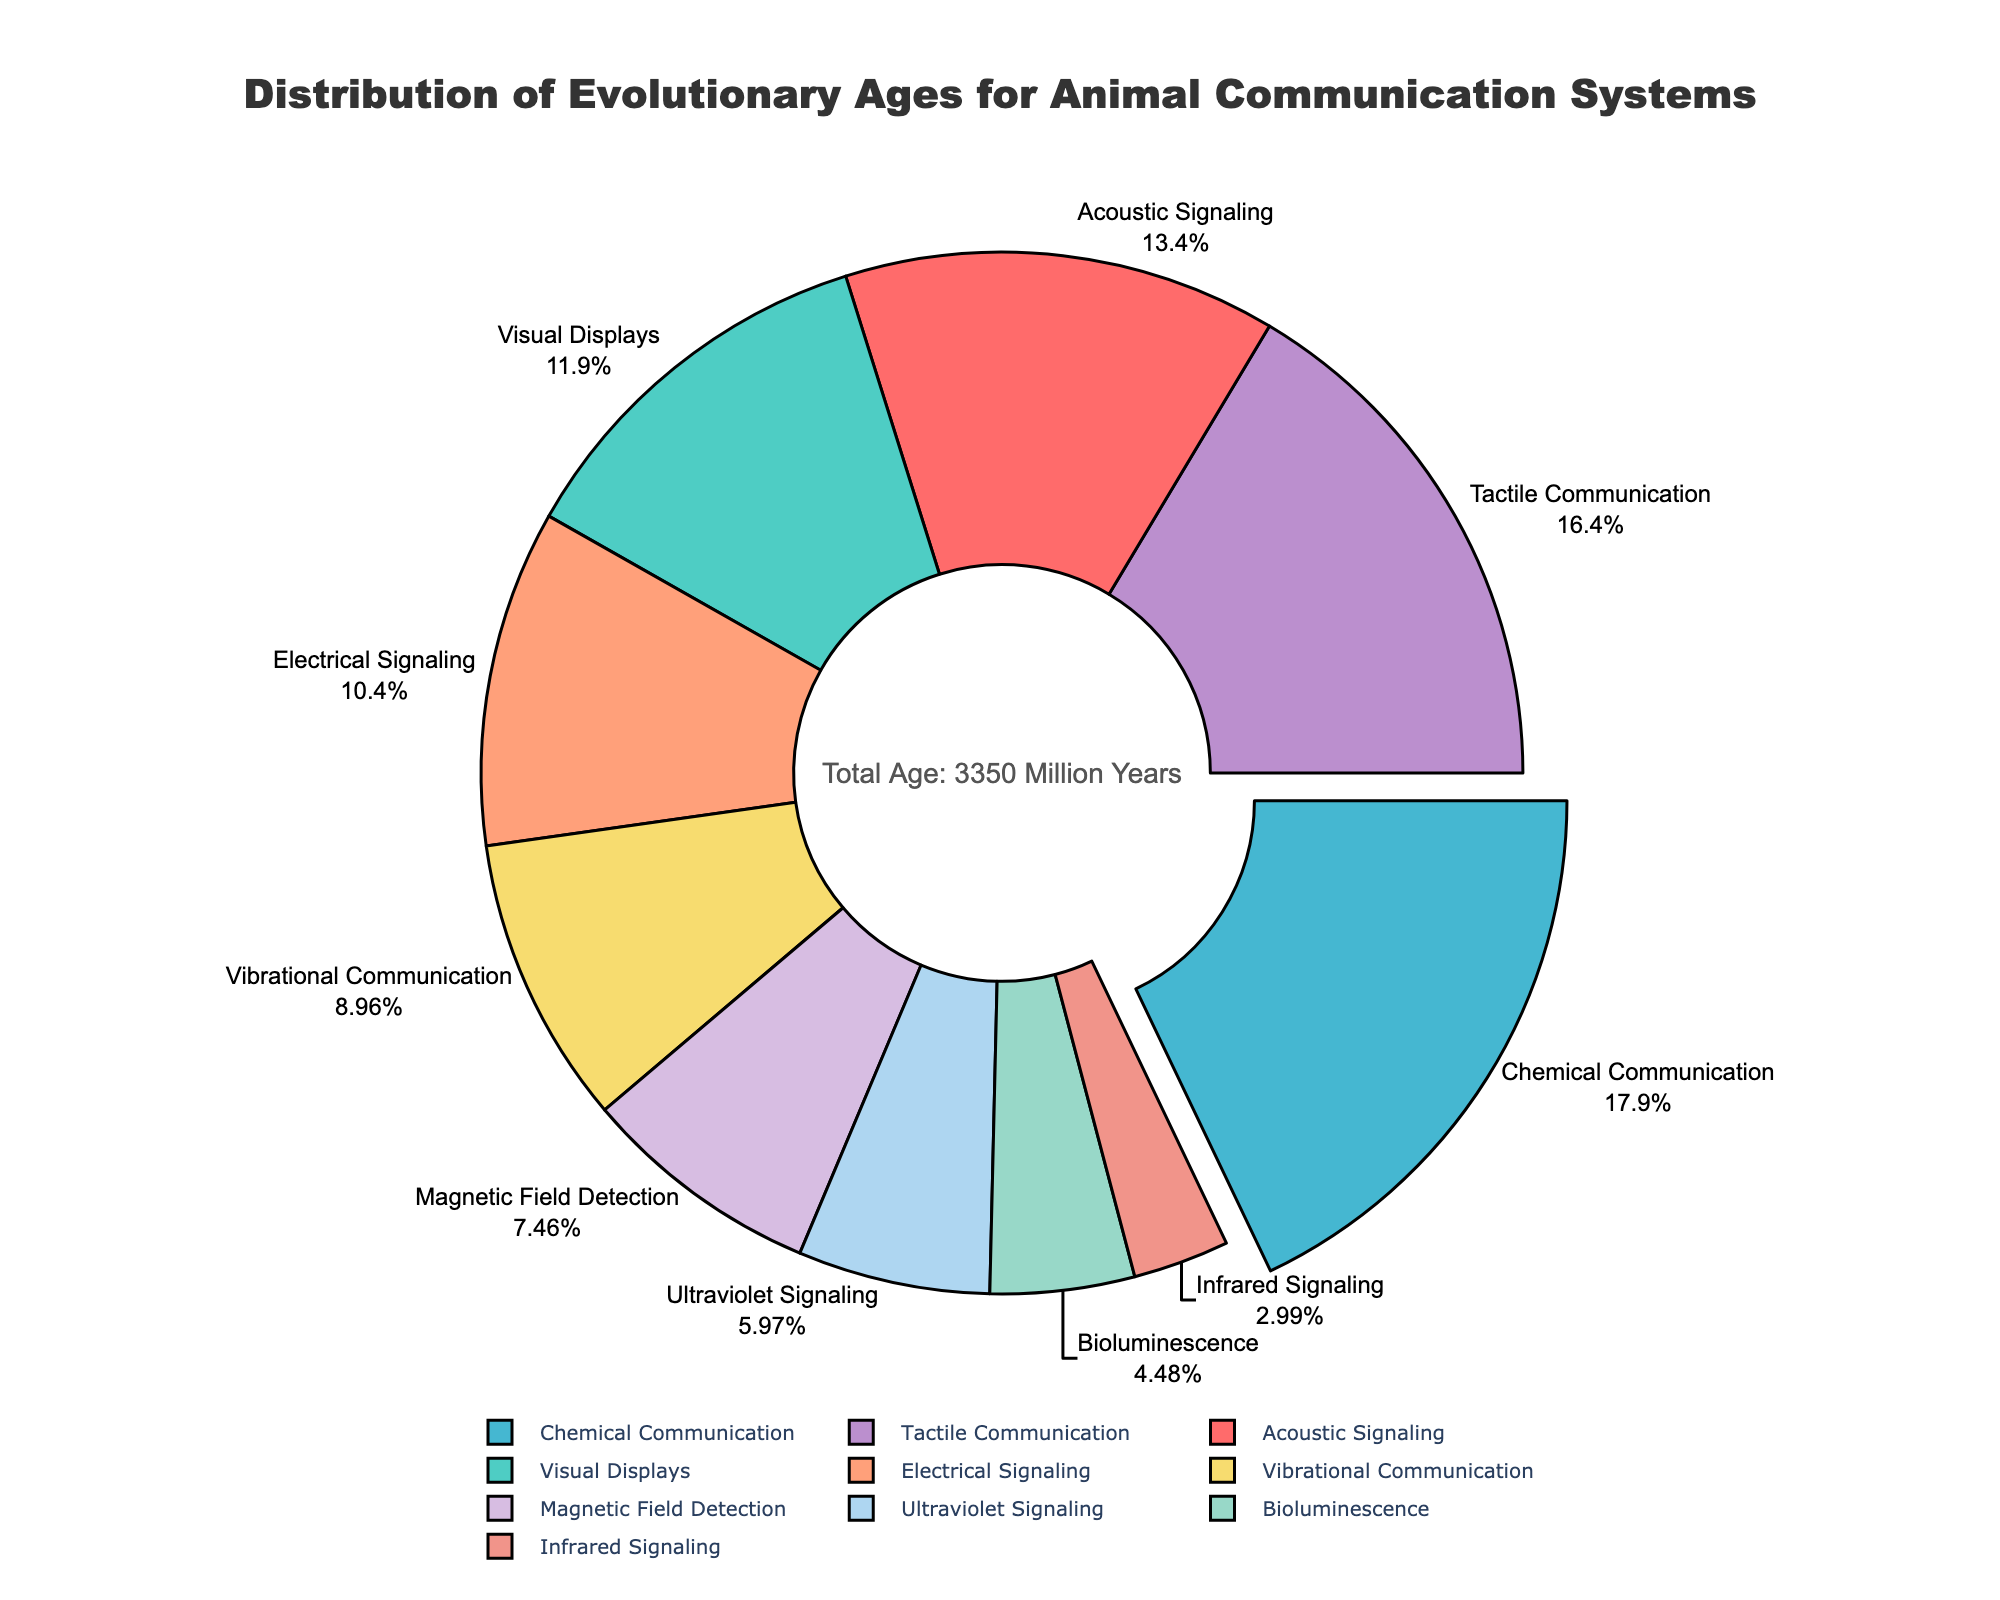Which type of animal communication system has the largest evolutionary age? Looking at the pie chart, the section with the largest percentage is pulled out and labeled as Chemical Communication.
Answer: Chemical Communication Which two types of animal communication systems together account for the highest evolutionary age? The highest combined evolutionary ages will have the largest combined percentages. Chemical Communication (32.26%) and Tactile Communication (29.57%) together have the highest total.
Answer: Chemical Communication and Tactile Communication What percentage of the total evolutionary age is accounted for by Visual Displays and Bioluminescence combined? From the pie chart, Visual Displays have 21.51% and Bioluminescence has 8.06%. Adding these percentages together gives us 21.51% + 8.06% = 29.57%.
Answer: 29.57% Which type of communication system has the smallest evolutionary age, and what is its percentage? The smallest section on the pie chart, representing Infrared Signaling, has a percentage of 3.23%.
Answer: Infrared Signaling, 3.23% How does the evolutionary age of Acoustic Signaling compare to that of Electrical Signaling? Acoustic Signaling has a larger slice than Electrical Signaling. By comparing the labels, Acoustic Signaling (24.19%) is greater than Electrical Signaling (16.13%).
Answer: Acoustic Signaling is older If the proportion of Vibrational Communication and Magnetic Field Detection were combined, would they surpass Visual Displays in percentage? Vibrational Communication (16.13%) combined with Magnetic Field Detection (13.44%) is 16.13% + 13.44% = 29.57%. Comparing to Visual Displays' 21.51%, the combined proportion is larger.
Answer: Yes List the animal communication systems that have an evolutionary age greater than 20% of the total. From the percentages on the pie chart, the types with more than 20% are Chemical Communication (32.26%), Tactile Communication (29.57%), and Acoustic Signaling (24.19%).
Answer: Chemical Communication, Tactile Communication, Acoustic Signaling Which communication system has an approximately equal evolutionary age to the combined ages of Ultraviolet Signaling and Infrared Signaling? Ultraviolet Signaling (12.90%) + Infrared Signaling (3.23%) = 16.13%, which corresponds to Vibrational Communication (16.13%) in the pie chart.
Answer: Vibrational Communication 